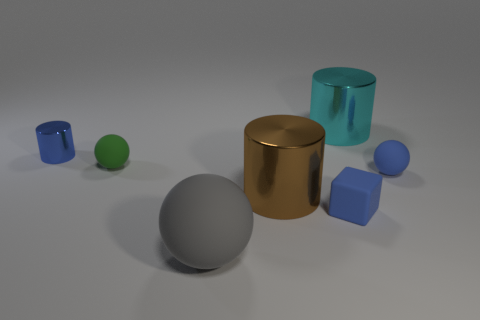Is there anything else that has the same shape as the small metal thing?
Your answer should be compact. Yes. There is a small sphere that is on the left side of the metal thing that is on the right side of the blue matte cube; what is its color?
Offer a terse response. Green. How many green matte things are there?
Your answer should be very brief. 1. What number of rubber objects are either large blue cubes or cyan objects?
Make the answer very short. 0. How many metallic objects are the same color as the block?
Your response must be concise. 1. There is a big cylinder that is in front of the big cylinder that is on the right side of the brown cylinder; what is its material?
Make the answer very short. Metal. The cyan metal cylinder is what size?
Your answer should be compact. Large. What number of objects are the same size as the cube?
Provide a succinct answer. 3. What number of other cyan metallic objects have the same shape as the cyan shiny object?
Offer a terse response. 0. Is the number of tiny green objects that are in front of the gray sphere the same as the number of metallic cylinders?
Make the answer very short. No. 